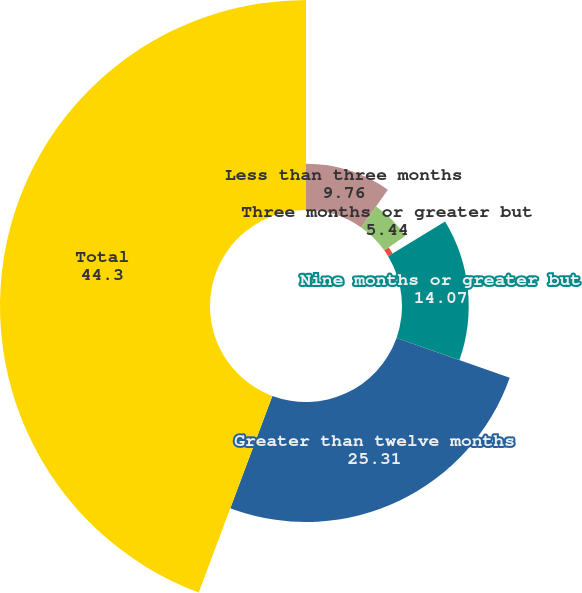Convert chart to OTSL. <chart><loc_0><loc_0><loc_500><loc_500><pie_chart><fcel>Less than three months<fcel>Three months or greater but<fcel>Six months or greater but less<fcel>Nine months or greater but<fcel>Greater than twelve months<fcel>Total<nl><fcel>9.76%<fcel>5.44%<fcel>1.12%<fcel>14.07%<fcel>25.31%<fcel>44.3%<nl></chart> 